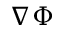Convert formula to latex. <formula><loc_0><loc_0><loc_500><loc_500>\nabla \Phi</formula> 